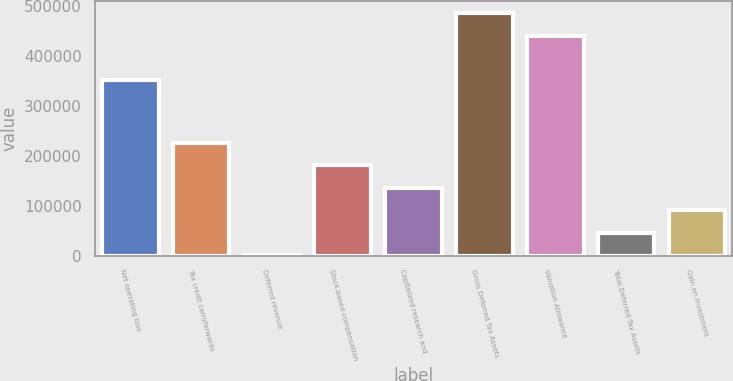Convert chart. <chart><loc_0><loc_0><loc_500><loc_500><bar_chart><fcel>Net operating loss<fcel>Tax credit carryforwards<fcel>Deferred revenue<fcel>Stock-based compensation<fcel>Capitalized research and<fcel>Gross Deferred Tax Assets<fcel>Valuation Allowance<fcel>Total Deferred Tax Assets<fcel>Gain on Investment<nl><fcel>352014<fcel>226372<fcel>343<fcel>181166<fcel>135960<fcel>486548<fcel>441342<fcel>45548.7<fcel>90754.4<nl></chart> 